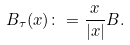<formula> <loc_0><loc_0><loc_500><loc_500>B _ { \tau } ( x ) \colon = \frac { x } { | x | } B .</formula> 